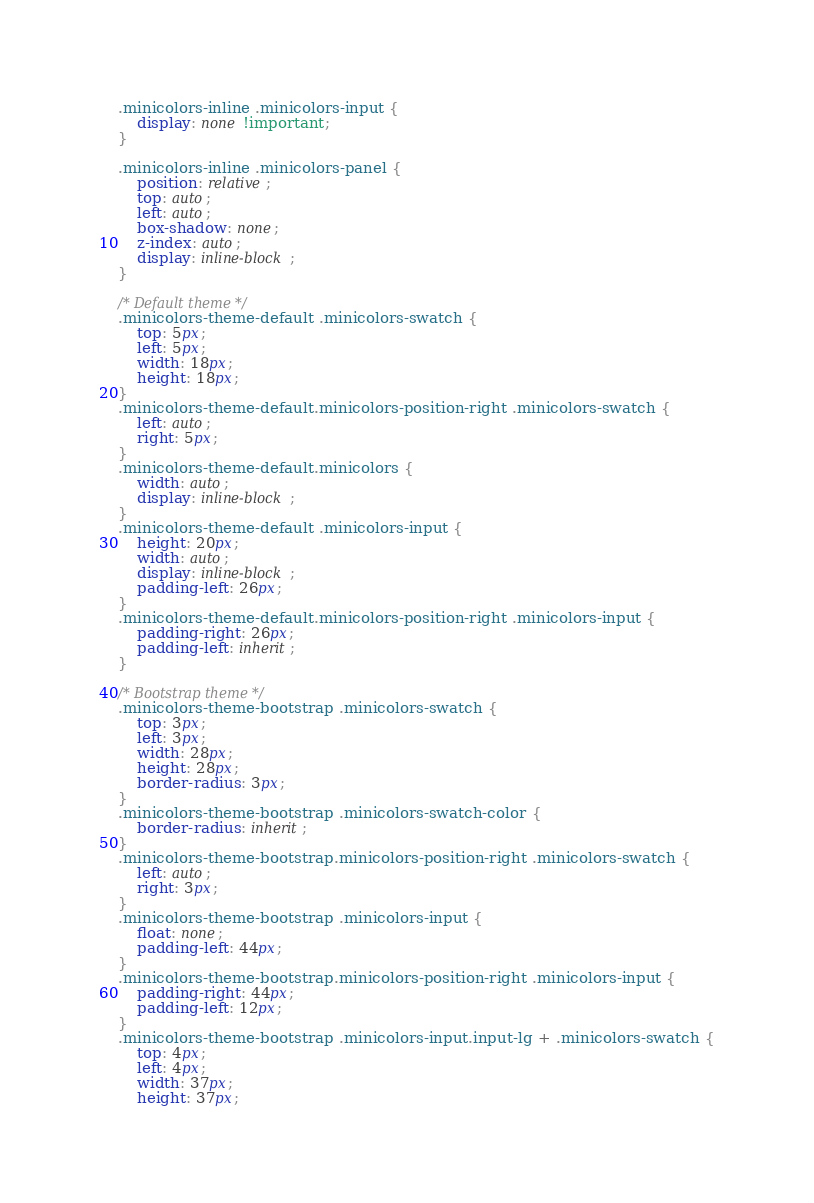<code> <loc_0><loc_0><loc_500><loc_500><_CSS_>
.minicolors-inline .minicolors-input {
    display: none !important;
}

.minicolors-inline .minicolors-panel {
    position: relative;
    top: auto;
    left: auto;
    box-shadow: none;
    z-index: auto;
    display: inline-block;
}

/* Default theme */
.minicolors-theme-default .minicolors-swatch {
    top: 5px;
    left: 5px;
    width: 18px;
    height: 18px;
}
.minicolors-theme-default.minicolors-position-right .minicolors-swatch {
    left: auto;
    right: 5px;
}
.minicolors-theme-default.minicolors {
    width: auto;
    display: inline-block;
}
.minicolors-theme-default .minicolors-input {
    height: 20px;
    width: auto;
    display: inline-block;
    padding-left: 26px;
}
.minicolors-theme-default.minicolors-position-right .minicolors-input {
    padding-right: 26px;
    padding-left: inherit;
}

/* Bootstrap theme */
.minicolors-theme-bootstrap .minicolors-swatch {
    top: 3px;
    left: 3px;
    width: 28px;
    height: 28px;
    border-radius: 3px;
}
.minicolors-theme-bootstrap .minicolors-swatch-color {
    border-radius: inherit;
}
.minicolors-theme-bootstrap.minicolors-position-right .minicolors-swatch {
    left: auto;
    right: 3px;
}
.minicolors-theme-bootstrap .minicolors-input {
    float: none;
    padding-left: 44px;
}
.minicolors-theme-bootstrap.minicolors-position-right .minicolors-input {
    padding-right: 44px;
    padding-left: 12px;
}
.minicolors-theme-bootstrap .minicolors-input.input-lg + .minicolors-swatch {
    top: 4px;
    left: 4px;
    width: 37px;
    height: 37px;</code> 